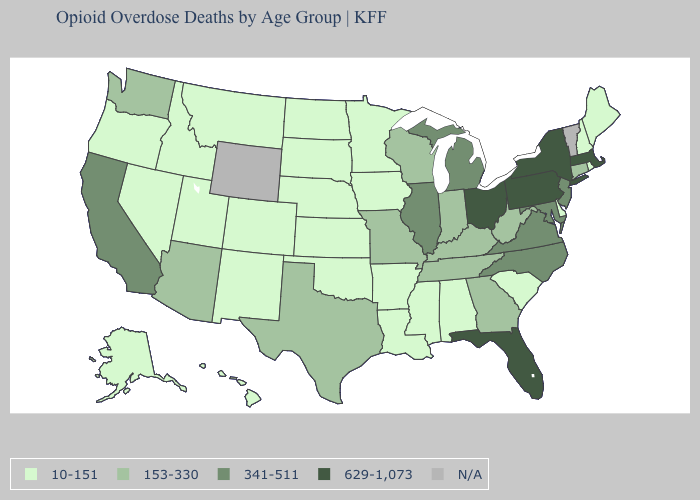Name the states that have a value in the range N/A?
Concise answer only. Vermont, Wyoming. Does New Jersey have the highest value in the Northeast?
Short answer required. No. How many symbols are there in the legend?
Give a very brief answer. 5. Is the legend a continuous bar?
Write a very short answer. No. Does the map have missing data?
Concise answer only. Yes. Name the states that have a value in the range 10-151?
Write a very short answer. Alabama, Alaska, Arkansas, Colorado, Delaware, Hawaii, Idaho, Iowa, Kansas, Louisiana, Maine, Minnesota, Mississippi, Montana, Nebraska, Nevada, New Hampshire, New Mexico, North Dakota, Oklahoma, Oregon, Rhode Island, South Carolina, South Dakota, Utah. Name the states that have a value in the range 153-330?
Concise answer only. Arizona, Connecticut, Georgia, Indiana, Kentucky, Missouri, Tennessee, Texas, Washington, West Virginia, Wisconsin. Does Pennsylvania have the lowest value in the Northeast?
Concise answer only. No. What is the value of Arizona?
Give a very brief answer. 153-330. Is the legend a continuous bar?
Short answer required. No. What is the value of Florida?
Quick response, please. 629-1,073. What is the value of Nevada?
Write a very short answer. 10-151. 